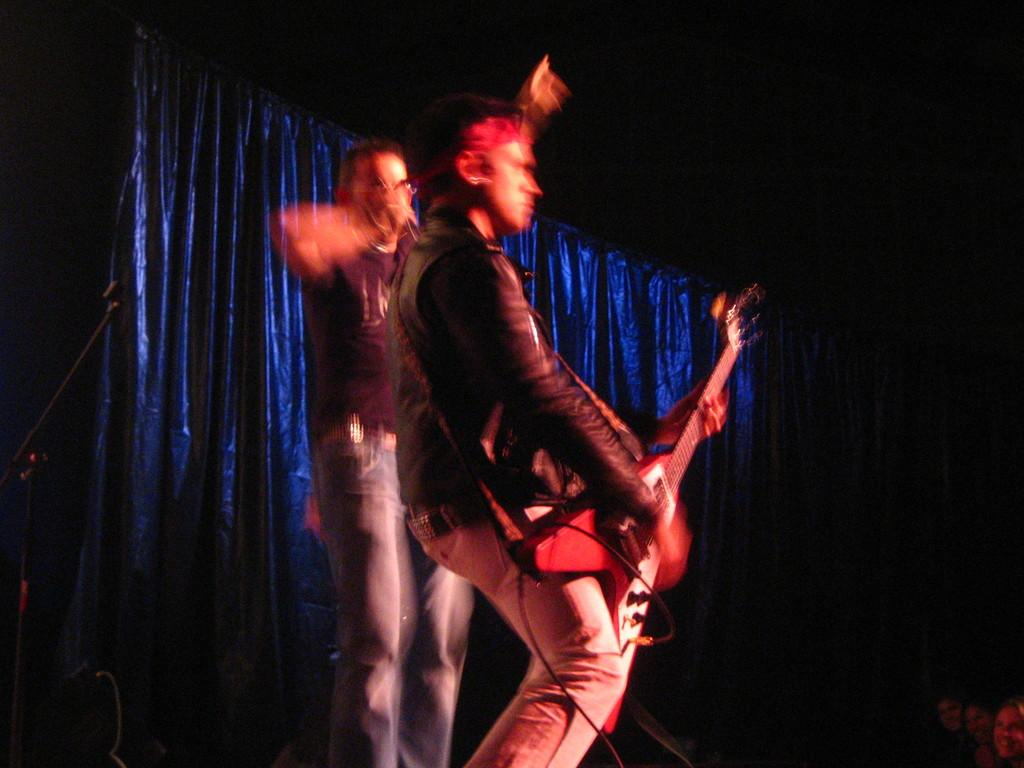What is the man in the image doing? The man in the image is standing and playing a guitar. Is there anyone else in the image? Yes, there is another man standing on the first man's back. What object is visible in the image that is commonly used for amplifying sound? There is a microphone visible in the image. What color is the curtain in the background of the image? The curtain in the background of the image is blue. What does the fireman do to the guitar in the image? There is no fireman present in the image, and therefore no interaction with the guitar can be observed. 